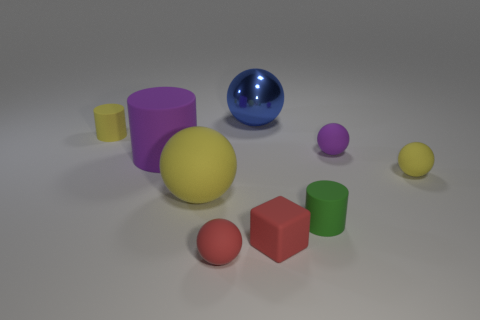Add 1 tiny red matte cylinders. How many objects exist? 10 Subtract all tiny purple matte balls. How many balls are left? 4 Subtract all blue balls. How many balls are left? 4 Subtract 1 cubes. How many cubes are left? 0 Add 6 tiny rubber balls. How many tiny rubber balls exist? 9 Subtract 1 green cylinders. How many objects are left? 8 Subtract all blocks. How many objects are left? 8 Subtract all blue spheres. Subtract all cyan cubes. How many spheres are left? 4 Subtract all cyan cubes. How many red spheres are left? 1 Subtract all blue metallic things. Subtract all tiny purple objects. How many objects are left? 7 